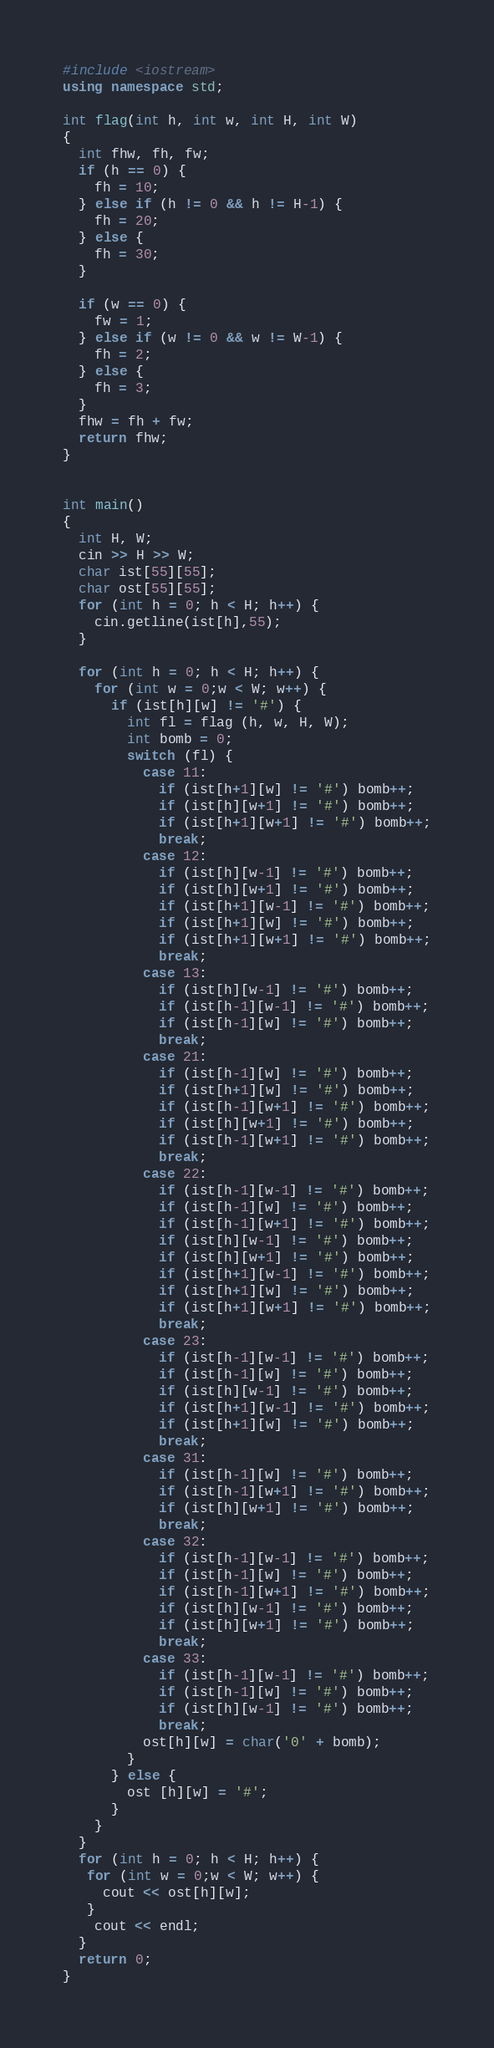Convert code to text. <code><loc_0><loc_0><loc_500><loc_500><_C++_>#include <iostream>
using namespace std;

int flag(int h, int w, int H, int W)
{
  int fhw, fh, fw;
  if (h == 0) {
    fh = 10;
  } else if (h != 0 && h != H-1) {
    fh = 20;
  } else {
    fh = 30;
  }
  
  if (w == 0) {
    fw = 1;
  } else if (w != 0 && w != W-1) {
    fh = 2;
  } else {
    fh = 3;
  }
  fhw = fh + fw;
  return fhw;
}


int main()
{
  int H, W;
  cin >> H >> W;
  char ist[55][55];
  char ost[55][55];
  for (int h = 0; h < H; h++) {
    cin.getline(ist[h],55);
  }
  
  for (int h = 0; h < H; h++) {
    for (int w = 0;w < W; w++) {
      if (ist[h][w] != '#') {
        int fl = flag (h, w, H, W);
        int bomb = 0;
        switch (fl) {
          case 11:
            if (ist[h+1][w] != '#') bomb++;
            if (ist[h][w+1] != '#') bomb++;
            if (ist[h+1][w+1] != '#') bomb++;
            break;
          case 12:
            if (ist[h][w-1] != '#') bomb++;
            if (ist[h][w+1] != '#') bomb++;
            if (ist[h+1][w-1] != '#') bomb++;
            if (ist[h+1][w] != '#') bomb++;
            if (ist[h+1][w+1] != '#') bomb++;
            break;
          case 13:
            if (ist[h][w-1] != '#') bomb++;
            if (ist[h-1][w-1] != '#') bomb++;
            if (ist[h-1][w] != '#') bomb++;
            break;
          case 21:
            if (ist[h-1][w] != '#') bomb++;
            if (ist[h+1][w] != '#') bomb++;
            if (ist[h-1][w+1] != '#') bomb++;
            if (ist[h][w+1] != '#') bomb++;
            if (ist[h-1][w+1] != '#') bomb++;
            break;
          case 22:
            if (ist[h-1][w-1] != '#') bomb++;
            if (ist[h-1][w] != '#') bomb++;
            if (ist[h-1][w+1] != '#') bomb++;
            if (ist[h][w-1] != '#') bomb++;
            if (ist[h][w+1] != '#') bomb++;
            if (ist[h+1][w-1] != '#') bomb++;
            if (ist[h+1][w] != '#') bomb++;
            if (ist[h+1][w+1] != '#') bomb++;
            break;
          case 23:
            if (ist[h-1][w-1] != '#') bomb++;
            if (ist[h-1][w] != '#') bomb++;
            if (ist[h][w-1] != '#') bomb++;
            if (ist[h+1][w-1] != '#') bomb++;
            if (ist[h+1][w] != '#') bomb++;
            break;
          case 31:
            if (ist[h-1][w] != '#') bomb++;
            if (ist[h-1][w+1] != '#') bomb++;
            if (ist[h][w+1] != '#') bomb++;
            break;
          case 32:
            if (ist[h-1][w-1] != '#') bomb++;
            if (ist[h-1][w] != '#') bomb++;
            if (ist[h-1][w+1] != '#') bomb++;
            if (ist[h][w-1] != '#') bomb++;
            if (ist[h][w+1] != '#') bomb++;
            break;
          case 33:
            if (ist[h-1][w-1] != '#') bomb++;
            if (ist[h-1][w] != '#') bomb++;
            if (ist[h][w-1] != '#') bomb++;
            break;
          ost[h][w] = char('0' + bomb);
        }
      } else {
        ost [h][w] = '#';
      }
    }
  }
  for (int h = 0; h < H; h++) {
   for (int w = 0;w < W; w++) {
     cout << ost[h][w];
   }
    cout << endl;
  }
  return 0;
}
</code> 